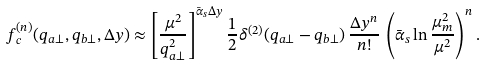<formula> <loc_0><loc_0><loc_500><loc_500>f ^ { ( n ) } _ { c } ( q _ { a \perp } , q _ { b \perp } , \Delta y ) \approx \left [ \frac { \mu ^ { 2 } } { q _ { a \perp } ^ { 2 } } \right ] ^ { \bar { \alpha } _ { s } \Delta y } \frac { 1 } { 2 } \delta ^ { ( 2 ) } ( q _ { a \perp } - q _ { b \perp } ) \, \frac { \Delta y ^ { n } } { n ! } \, \left ( \bar { \alpha } _ { s } \ln \frac { \mu _ { m } ^ { 2 } } { \mu ^ { 2 } } \right ) ^ { n } .</formula> 